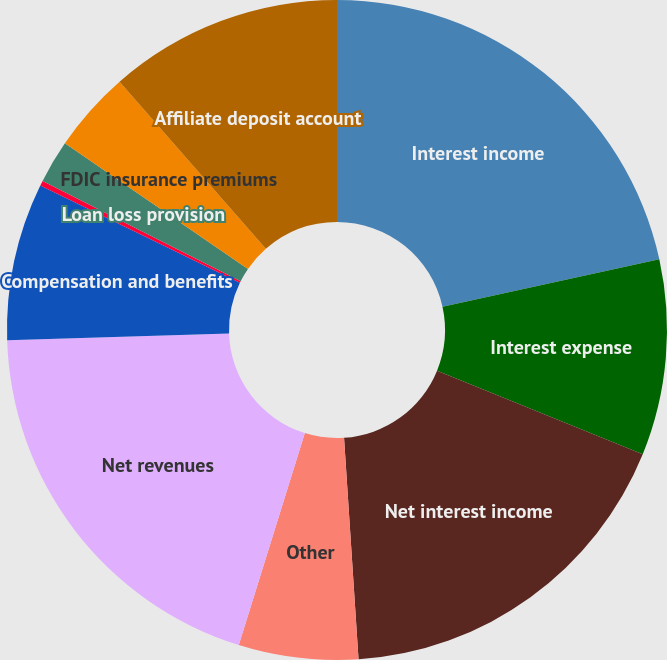Convert chart. <chart><loc_0><loc_0><loc_500><loc_500><pie_chart><fcel>Interest income<fcel>Interest expense<fcel>Net interest income<fcel>Other<fcel>Net revenues<fcel>Compensation and benefits<fcel>Communications and information<fcel>Loan loss provision<fcel>FDIC insurance premiums<fcel>Affiliate deposit account<nl><fcel>21.56%<fcel>9.58%<fcel>17.82%<fcel>5.85%<fcel>19.69%<fcel>7.71%<fcel>0.25%<fcel>2.11%<fcel>3.98%<fcel>11.45%<nl></chart> 